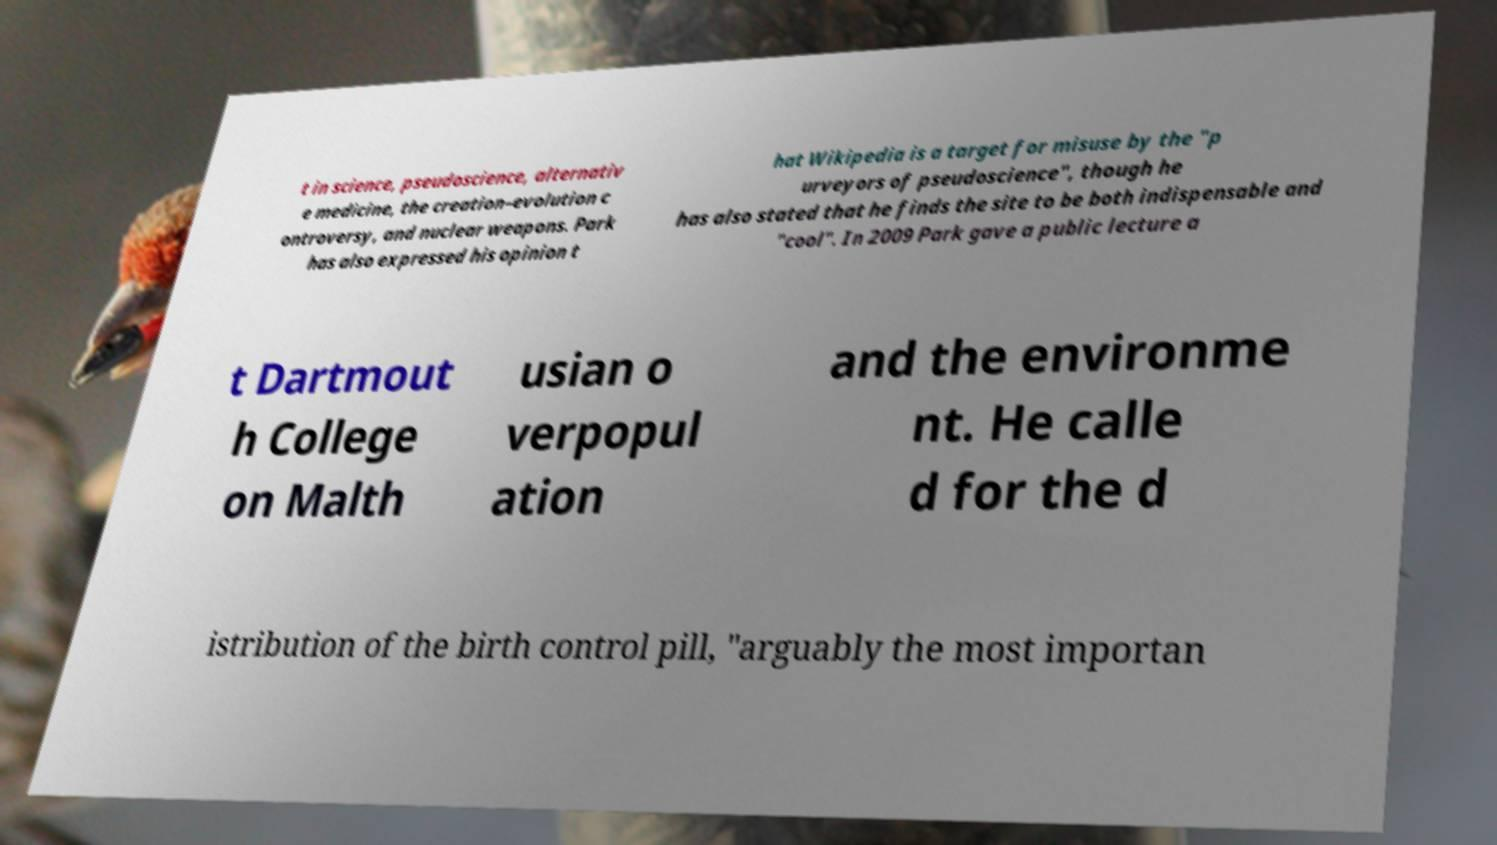What messages or text are displayed in this image? I need them in a readable, typed format. t in science, pseudoscience, alternativ e medicine, the creation–evolution c ontroversy, and nuclear weapons. Park has also expressed his opinion t hat Wikipedia is a target for misuse by the "p urveyors of pseudoscience", though he has also stated that he finds the site to be both indispensable and "cool". In 2009 Park gave a public lecture a t Dartmout h College on Malth usian o verpopul ation and the environme nt. He calle d for the d istribution of the birth control pill, "arguably the most importan 